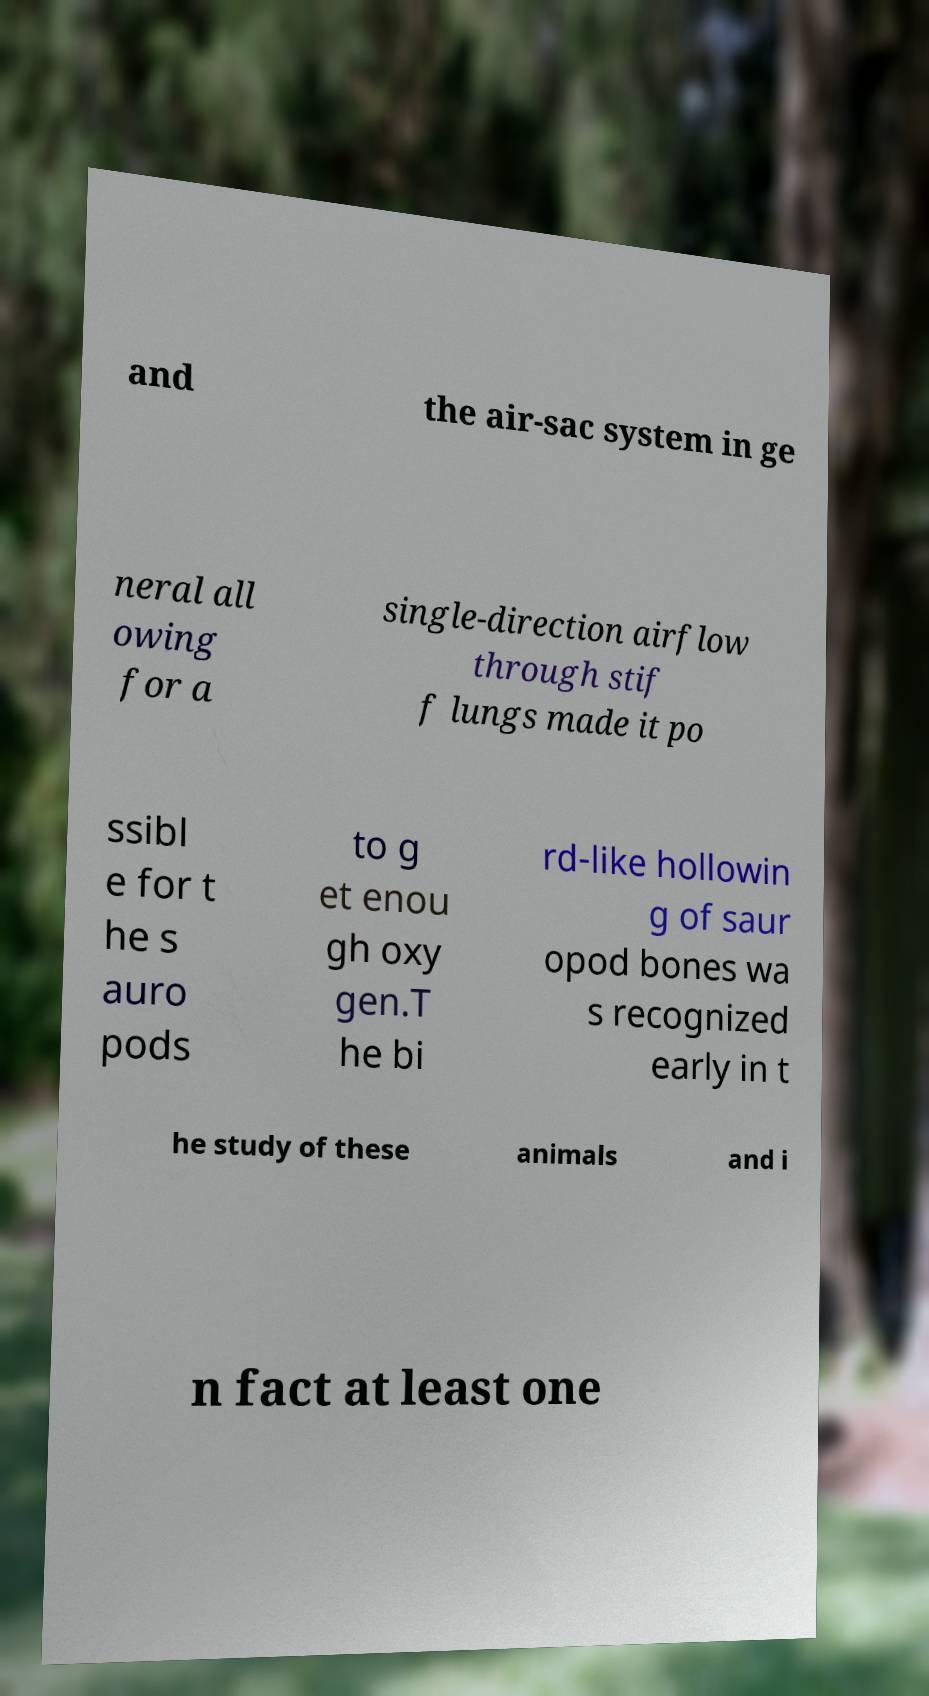What messages or text are displayed in this image? I need them in a readable, typed format. and the air-sac system in ge neral all owing for a single-direction airflow through stif f lungs made it po ssibl e for t he s auro pods to g et enou gh oxy gen.T he bi rd-like hollowin g of saur opod bones wa s recognized early in t he study of these animals and i n fact at least one 